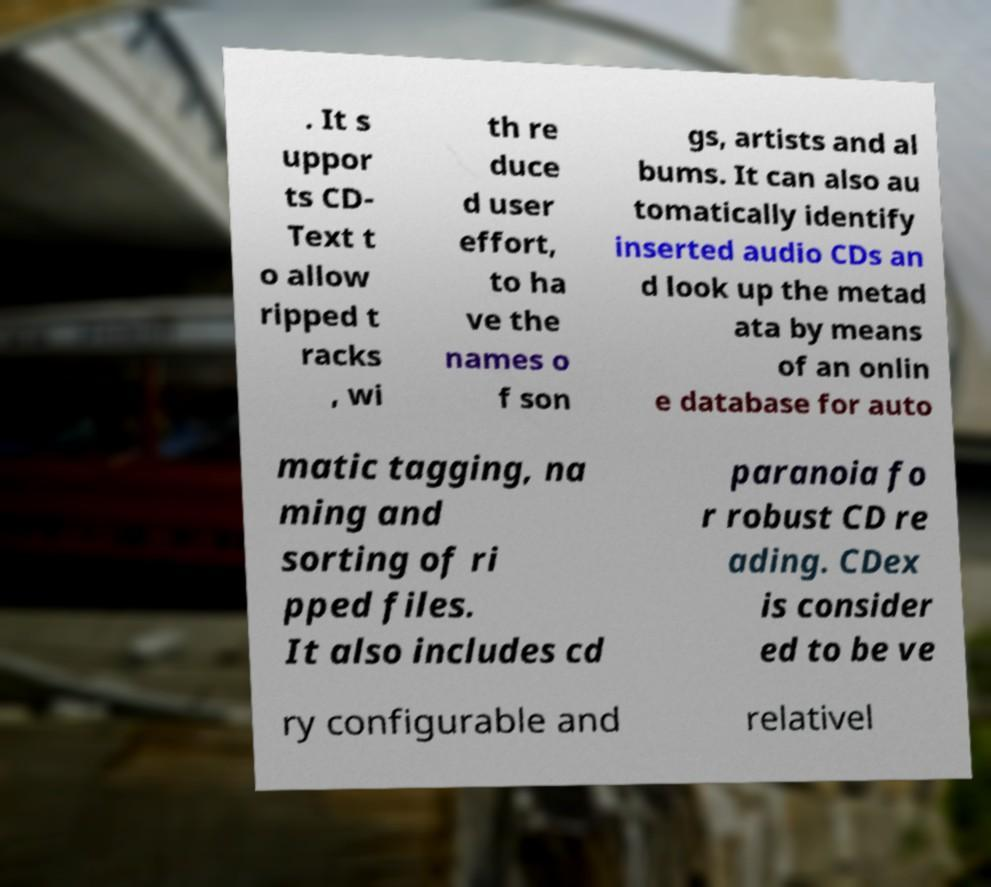Could you assist in decoding the text presented in this image and type it out clearly? . It s uppor ts CD- Text t o allow ripped t racks , wi th re duce d user effort, to ha ve the names o f son gs, artists and al bums. It can also au tomatically identify inserted audio CDs an d look up the metad ata by means of an onlin e database for auto matic tagging, na ming and sorting of ri pped files. It also includes cd paranoia fo r robust CD re ading. CDex is consider ed to be ve ry configurable and relativel 